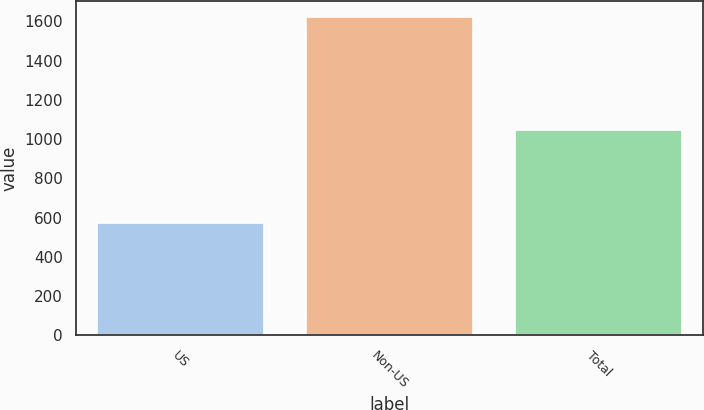Convert chart. <chart><loc_0><loc_0><loc_500><loc_500><bar_chart><fcel>US<fcel>Non-US<fcel>Total<nl><fcel>575<fcel>1623<fcel>1048<nl></chart> 